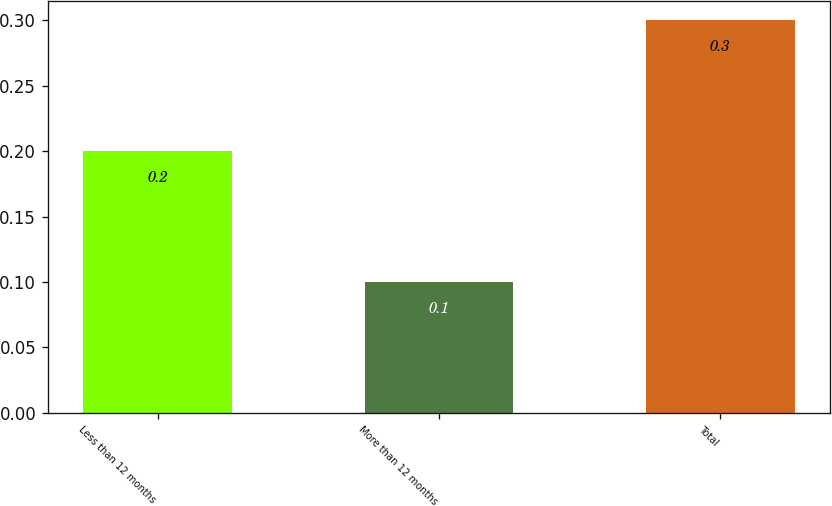Convert chart to OTSL. <chart><loc_0><loc_0><loc_500><loc_500><bar_chart><fcel>Less than 12 months<fcel>More than 12 months<fcel>Total<nl><fcel>0.2<fcel>0.1<fcel>0.3<nl></chart> 